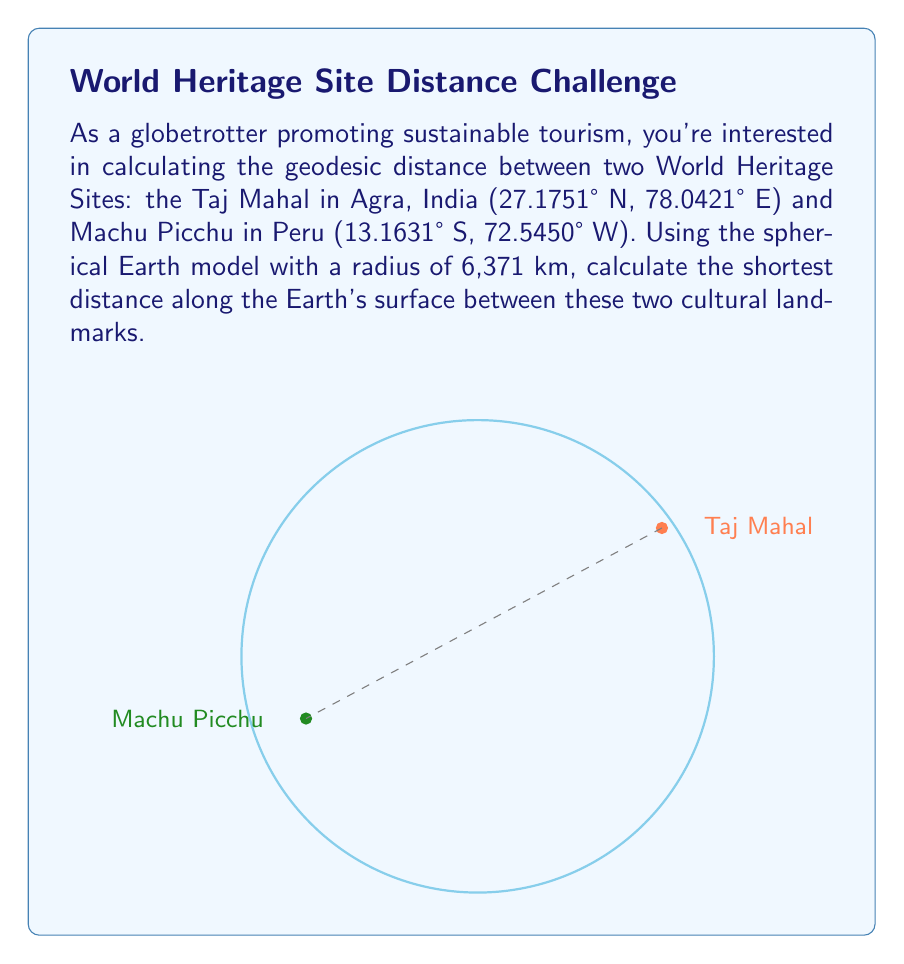Teach me how to tackle this problem. To calculate the geodesic distance between two points on the Earth's surface, we'll use the Haversine formula. This formula provides a good approximation for the great-circle distance between two points on a sphere.

Step 1: Convert the coordinates from degrees to radians.
Taj Mahal: $\phi_1 = 27.1751° \times \frac{\pi}{180} = 0.4742$ rad, $\lambda_1 = 78.0421° \times \frac{\pi}{180} = 1.3619$ rad
Machu Picchu: $\phi_2 = -13.1631° \times \frac{\pi}{180} = -0.2297$ rad, $\lambda_2 = -72.5450° \times \frac{\pi}{180} = -1.2661$ rad

Step 2: Calculate the differences in latitude and longitude.
$\Delta\phi = \phi_2 - \phi_1 = -0.2297 - 0.4742 = -0.7039$ rad
$\Delta\lambda = \lambda_2 - \lambda_1 = -1.2661 - 1.3619 = -2.6280$ rad

Step 3: Apply the Haversine formula:
$$a = \sin^2(\frac{\Delta\phi}{2}) + \cos(\phi_1) \cos(\phi_2) \sin^2(\frac{\Delta\lambda}{2})$$
$$c = 2 \times \arctan2(\sqrt{a}, \sqrt{1-a})$$
$$d = R \times c$$

Where $R$ is the Earth's radius (6,371 km).

Step 4: Calculate the intermediate values:
$a = \sin^2(-0.3520) + \cos(0.4742) \cos(-0.2297) \sin^2(-1.3140) = 0.6915$
$c = 2 \times \arctan2(\sqrt{0.6915}, \sqrt{1-0.6915}) = 2.3053$

Step 5: Calculate the final distance:
$d = 6371 \times 2.3053 = 14,686.06$ km
Answer: 14,686 km 